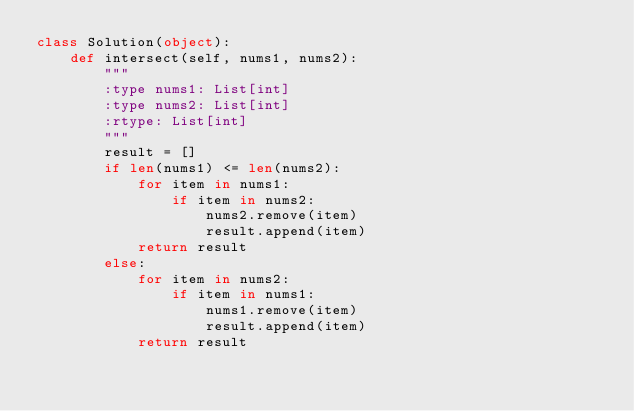<code> <loc_0><loc_0><loc_500><loc_500><_Python_>class Solution(object):
    def intersect(self, nums1, nums2):
        """
        :type nums1: List[int]
        :type nums2: List[int]
        :rtype: List[int]
        """
        result = []
        if len(nums1) <= len(nums2):
            for item in nums1:
                if item in nums2:
                    nums2.remove(item)
                    result.append(item)
            return result
        else:
            for item in nums2:
                if item in nums1:
                    nums1.remove(item)
                    result.append(item)
            return result</code> 